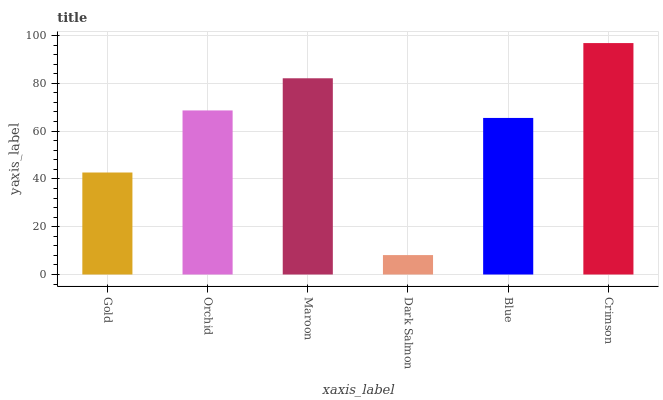Is Dark Salmon the minimum?
Answer yes or no. Yes. Is Crimson the maximum?
Answer yes or no. Yes. Is Orchid the minimum?
Answer yes or no. No. Is Orchid the maximum?
Answer yes or no. No. Is Orchid greater than Gold?
Answer yes or no. Yes. Is Gold less than Orchid?
Answer yes or no. Yes. Is Gold greater than Orchid?
Answer yes or no. No. Is Orchid less than Gold?
Answer yes or no. No. Is Orchid the high median?
Answer yes or no. Yes. Is Blue the low median?
Answer yes or no. Yes. Is Crimson the high median?
Answer yes or no. No. Is Orchid the low median?
Answer yes or no. No. 